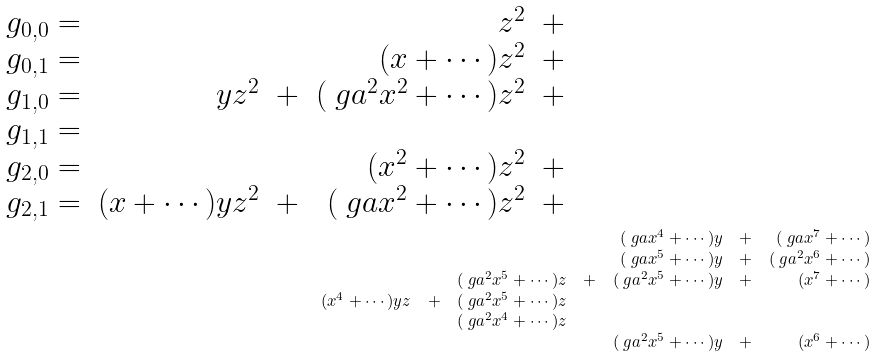<formula> <loc_0><loc_0><loc_500><loc_500>\begin{array} { c r r r r r r r r r r r r r r r r r } g _ { 0 , 0 } = & & & z ^ { 2 } & + & \quad & \quad & \quad & \quad & \quad & \quad & \\ g _ { 0 , 1 } = & & & ( x + \cdots ) z ^ { 2 } & + & & & & & & & \\ g _ { 1 , 0 } = & y z ^ { 2 } & + & ( \ g a ^ { 2 } x ^ { 2 } + \cdots ) z ^ { 2 } & + & & & & & & & \\ g _ { 1 , 1 } = & & & & & & & & & & & \\ g _ { 2 , 0 } = & & & ( x ^ { 2 } + \cdots ) z ^ { 2 } & + & & & & & & & \\ g _ { 2 , 1 } = & ( x + \cdots ) y z ^ { 2 } & + & ( \ g a x ^ { 2 } + \cdots ) z ^ { 2 } & + & & & & & & & \end{array} \\ \begin{array} { c r r r r r r r r r r r r r r r r r } & & & & & ( \ g a x ^ { 4 } + \cdots ) y & + & ( \ g a x ^ { 7 } + \cdots ) \\ & & & & & ( \ g a x ^ { 5 } + \cdots ) y & + & ( \ g a ^ { 2 } x ^ { 6 } + \cdots ) \\ & & & ( \ g a ^ { 2 } x ^ { 5 } + \cdots ) z & + & ( \ g a ^ { 2 } x ^ { 5 } + \cdots ) y & + & ( x ^ { 7 } + \cdots ) \\ & ( x ^ { 4 } + \cdots ) y z & + & ( \ g a ^ { 2 } x ^ { 5 } + \cdots ) z & & & & \\ & & & ( \ g a ^ { 2 } x ^ { 4 } + \cdots ) z & & & & \\ & & & & & ( \ g a ^ { 2 } x ^ { 5 } + \cdots ) y & + & ( x ^ { 6 } + \cdots ) \end{array}</formula> 